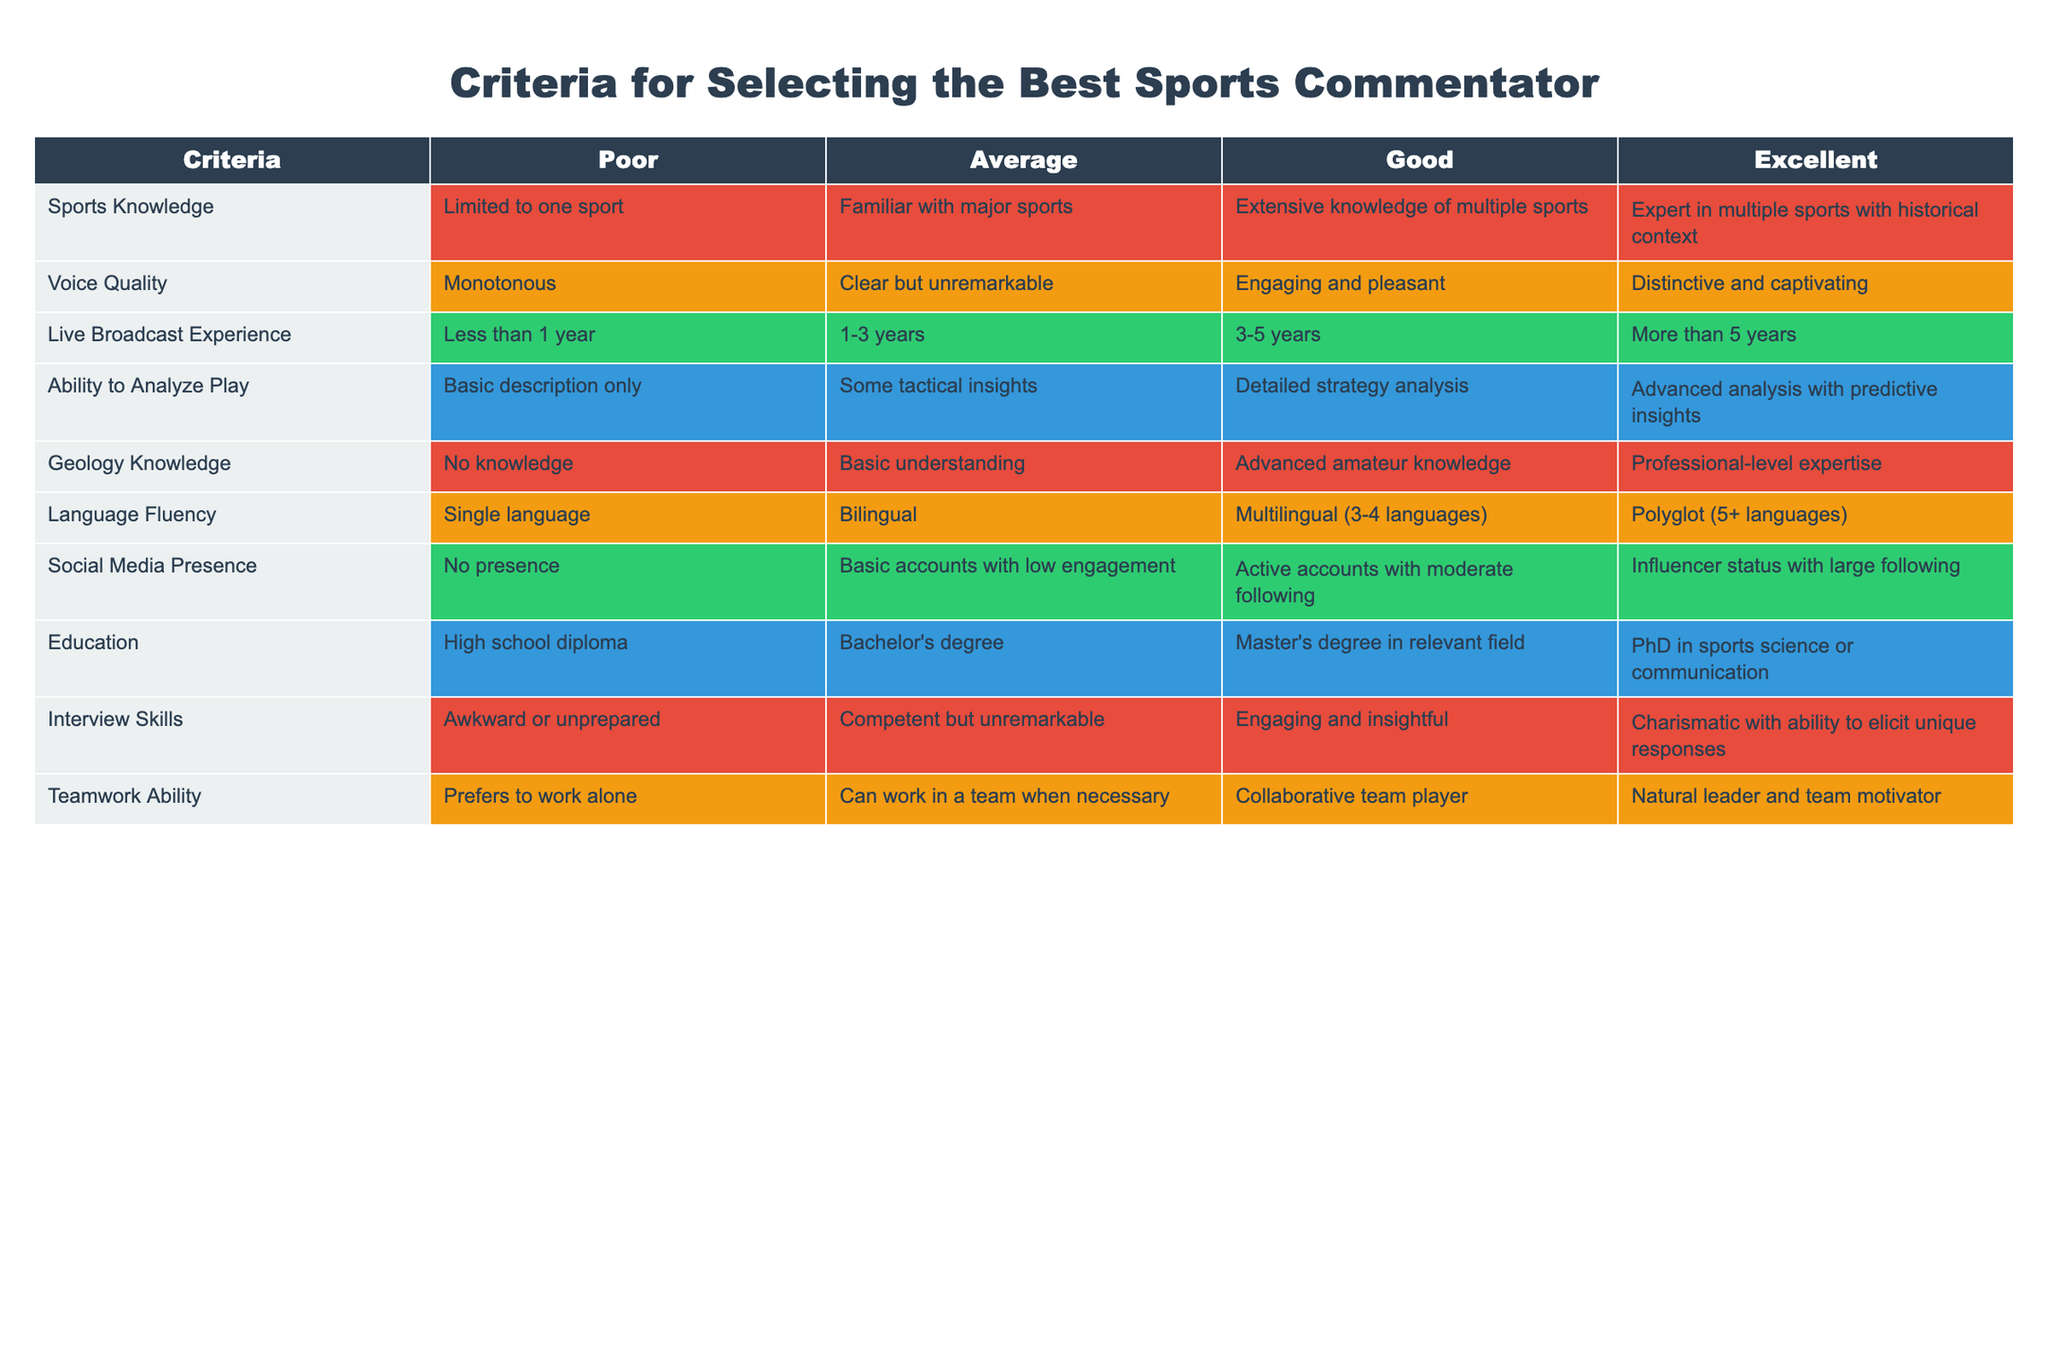What is the best rating for Geology Knowledge among candidates? The table shows the ratings for Geology Knowledge as Poor, Average, Good, and Excellent. The highest rating is Excellent.
Answer: Excellent How many years of live broadcast experience correspond to an Average rating? The table specifies that an Average rating for Live Broadcast Experience corresponds to 1-3 years.
Answer: 1-3 years Is it true that a candidate with a PhD in sports science or communication will always have excellent voice quality? The table does not explicitly state a direct relationship between education and voice quality, as these are independent criteria. No, having a PhD does not guarantee excellent voice quality.
Answer: No What could be the maximum combined score for a candidate in Sports Knowledge and Language Fluency? The maximum ratings in both categories are Excellent for both Sports Knowledge and Language Fluency. Since Excellent is the highest, the maximum score would be Excellent + Excellent, which stays Excellent as they are mutually exclusive categories.
Answer: Excellent Which candidate would likely have the most engaging interview skills? Candidates rated as Excellent in Interview Skills are characterized as being charismatic with the ability to elicit unique responses.
Answer: Charismatic with unique responses What is the difference in rating between someone with Basic understanding and Professional-level expertise in Geology Knowledge? The difference is between the Average rating (Basic understanding) and Excellent rating (Professional-level expertise). Poor is 1 point, Average is 2 points, Good is 3 points, and Excellent is 4 points. The difference is 4 - 2 = 2.
Answer: 2 points How many categories does a candidate have to excel in to be considered an influencer on social media? The table shows four levels for Social Media Presence, and a candidate must be rated at Excellent to be considered an influencer, indicating a large following and high engagement.
Answer: 1 category (Excellent) Calculate the average level of Sports Knowledge required for candidates rated Good and Excellent. To find the average, consider Poor (1), Average (2), Good (3), and Excellent (4). The average of Good (3) and Excellent (4) is calculated as (3 + 4) / 2 = 3.5, which corresponds to a Good rating leaning towards Excellent.
Answer: Good (3.5) 